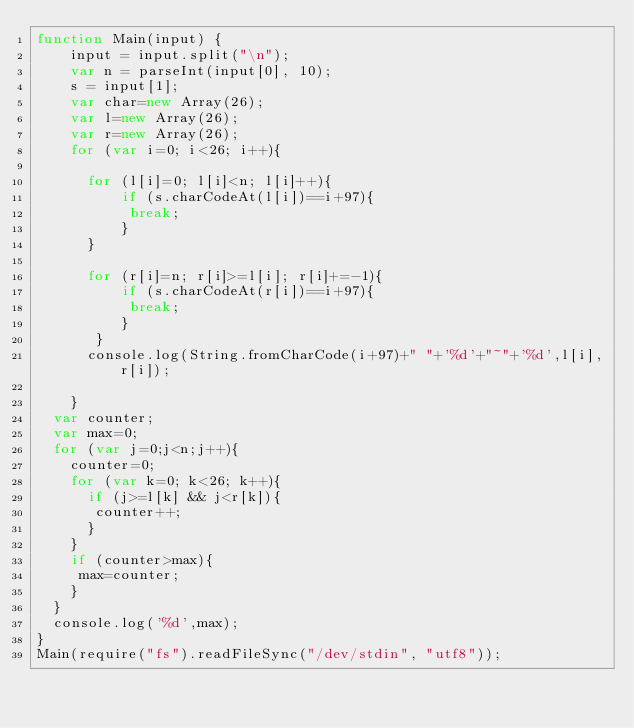Convert code to text. <code><loc_0><loc_0><loc_500><loc_500><_JavaScript_>function Main(input) {
  	input = input.split("\n");
  	var n = parseInt(input[0], 10);
  	s = input[1];
  	var char=new Array(26);
  	var l=new Array(26);
  	var r=new Array(26);
  	for (var i=0; i<26; i++){
      
      for (l[i]=0; l[i]<n; l[i]++){
          if (s.charCodeAt(l[i])==i+97){
           break; 
          }
      }
      
      for (r[i]=n; r[i]>=l[i]; r[i]+=-1){
          if (s.charCodeAt(r[i])==i+97){
           break; 
          }
       }
      console.log(String.fromCharCode(i+97)+" "+'%d'+"~"+'%d',l[i],r[i]);
      
    }
  var counter;
  var max=0;
  for (var j=0;j<n;j++){
    counter=0;
    for (var k=0; k<26; k++){
      if (j>=l[k] && j<r[k]){
       counter++; 
      }
    }
    if (counter>max){
     max=counter; 
    }
  }
  console.log('%d',max);
}
Main(require("fs").readFileSync("/dev/stdin", "utf8"));</code> 